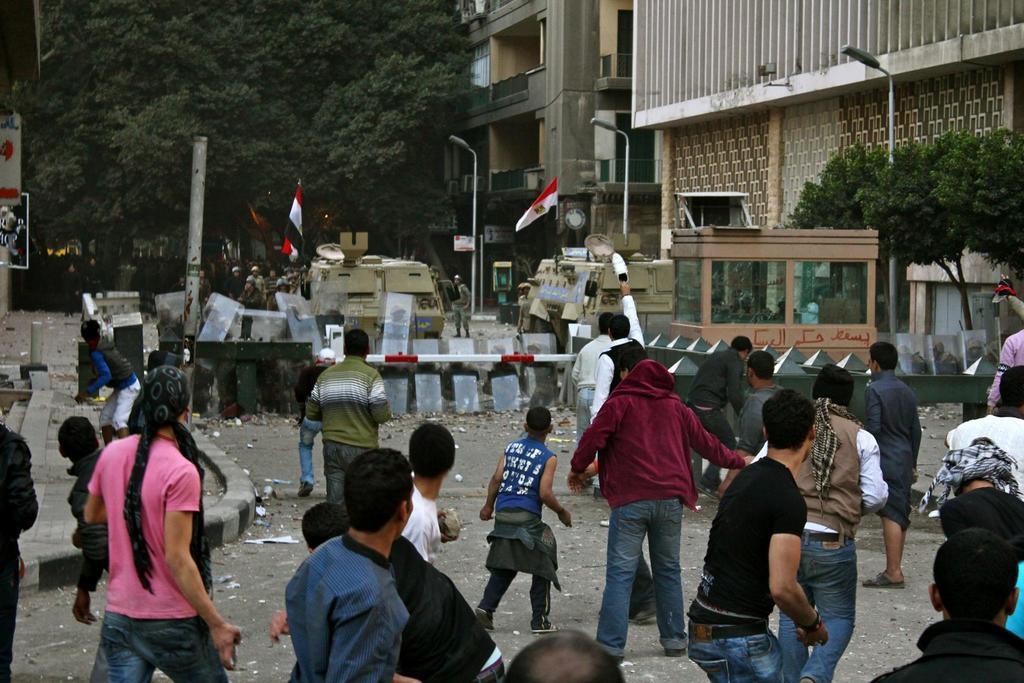Could you give a brief overview of what you see in this image? In this image we can see some people on the road and we can see the barricades in the middle of the road and there are few vehicles. We can see flags on the vehicles and there are few street lights and we can see some buildings and trees. 